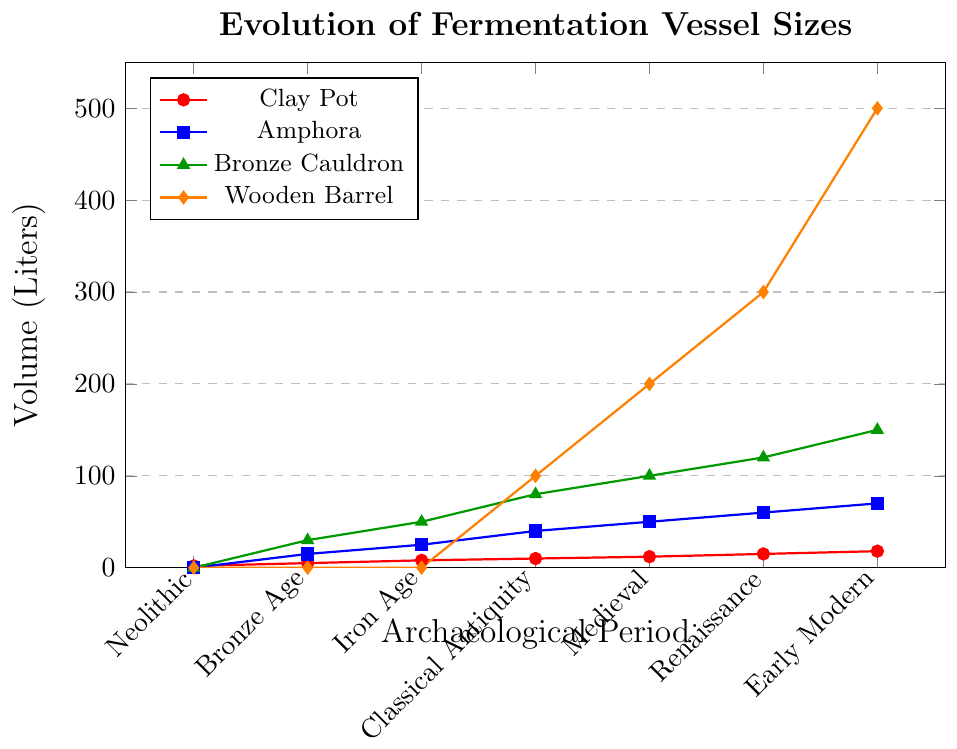What is the volumetric change of Clay Pot from Neolithic to Early Modern Period? The volume of Clay Pot in the Neolithic period is 2 liters and in the Early Modern period is 18 liters. The change can be calculated by subtracting the initial volume from the final volume: 18 - 2 = 16 liters.
Answer: 16 liters Which vessel type had the greatest increase in volume during the Classical Antiquity period compared to the Iron Age? To find this, compare the volumes of all vessel types between the Iron Age and Classical Antiquity periods. The volumes for the Iron Age are Clay Pot: 8, Amphora: 25, Bronze Cauldron: 50, Wooden Barrel: 0. For Classical Antiquity, they are Clay Pot: 10, Amphora: 40, Bronze Cauldron: 80, Wooden Barrel: 100. The increases are: Clay Pot: 2 liters, Amphora: 15 liters, Bronze Cauldron: 30 liters, Wooden Barrel: 100 liters. The greatest increase is for Wooden Barrel at 100 liters.
Answer: Wooden Barrel How does the volume of Amphora compare to that of the Bronze Cauldron in the Renaissance period? In the Renaissance period, the volume for Amphora is 60 liters, and for the Bronze Cauldron, it is 120 liters.
Answer: Bronze Cauldron is twice the Amphora At which period did the Wooden Barrel start to appear and what was its initial volume? The Wooden Barrel first appears during the Classical Antiquity period with an initial volume of 100 liters.
Answer: Classical Antiquity, 100 liters Calculate the average volume of Amphora over all the periods. The volumes of Amphora over the periods are: 0, 15, 25, 40, 50, 60, 70. To find the average, sum these volumes and divide by the number of periods: (0 + 15 + 25 + 40 + 50 + 60 + 70) / 7 = 260 / 7 ≈ 37.1 liters.
Answer: 37.1 liters Which vessel consistently increases in volume in every successive period? Observing the data, the Clay Pot has a consistent increase in volume in every period from 2 liters in Neolithic to 18 liters in Early Modern Period.
Answer: Clay Pot Compare the volume of all vessel types during the Iron Age. Which has the highest and the lowest volumes? During the Iron Age, the volumes are: Clay Pot: 8 liters, Amphora: 25 liters, Bronze Cauldron: 50 liters, Wooden Barrel: 0 liters. The Bronze Cauldron has the highest volume at 50 liters, and the Wooden Barrel has the lowest at 0 liters.
Answer: Bronze Cauldron, Wooden Barrel What period shows the first appearance of Bronze Cauldrons and what volume do they start with? The Bronze Cauldron first appears during the Bronze Age with a volume of 30 liters.
Answer: Bronze Age, 30 liters 